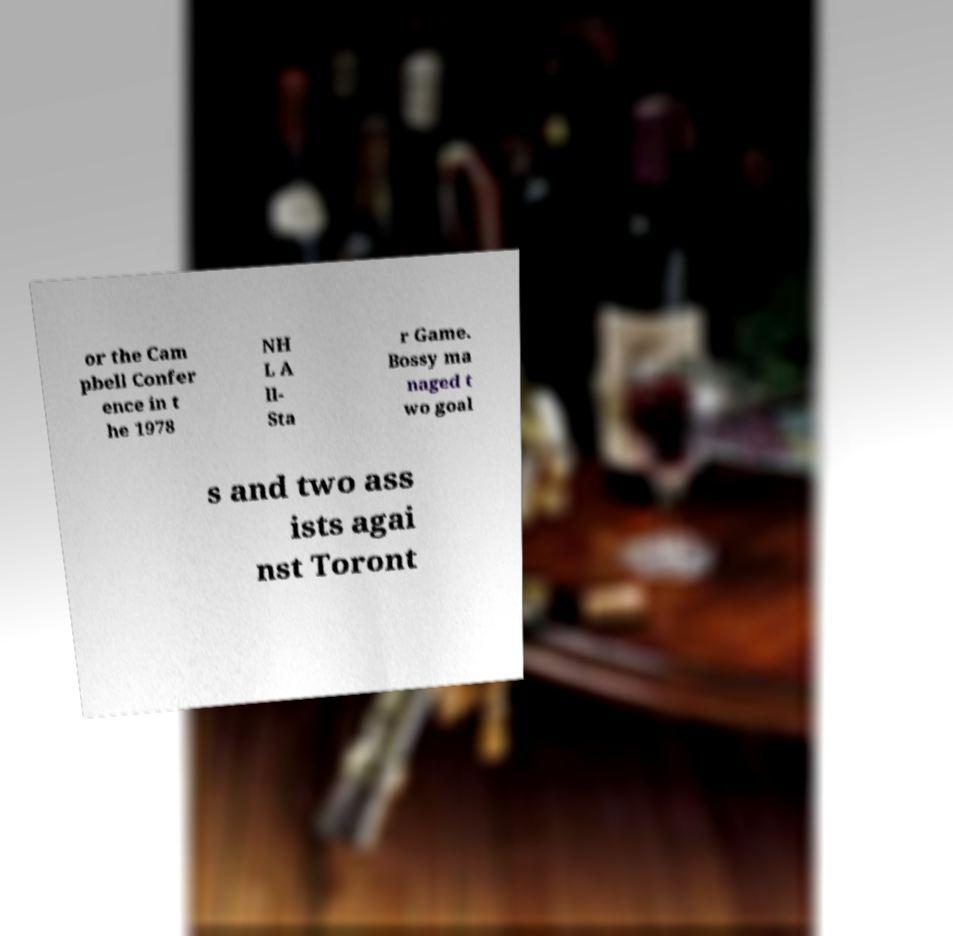Could you extract and type out the text from this image? or the Cam pbell Confer ence in t he 1978 NH L A ll- Sta r Game. Bossy ma naged t wo goal s and two ass ists agai nst Toront 